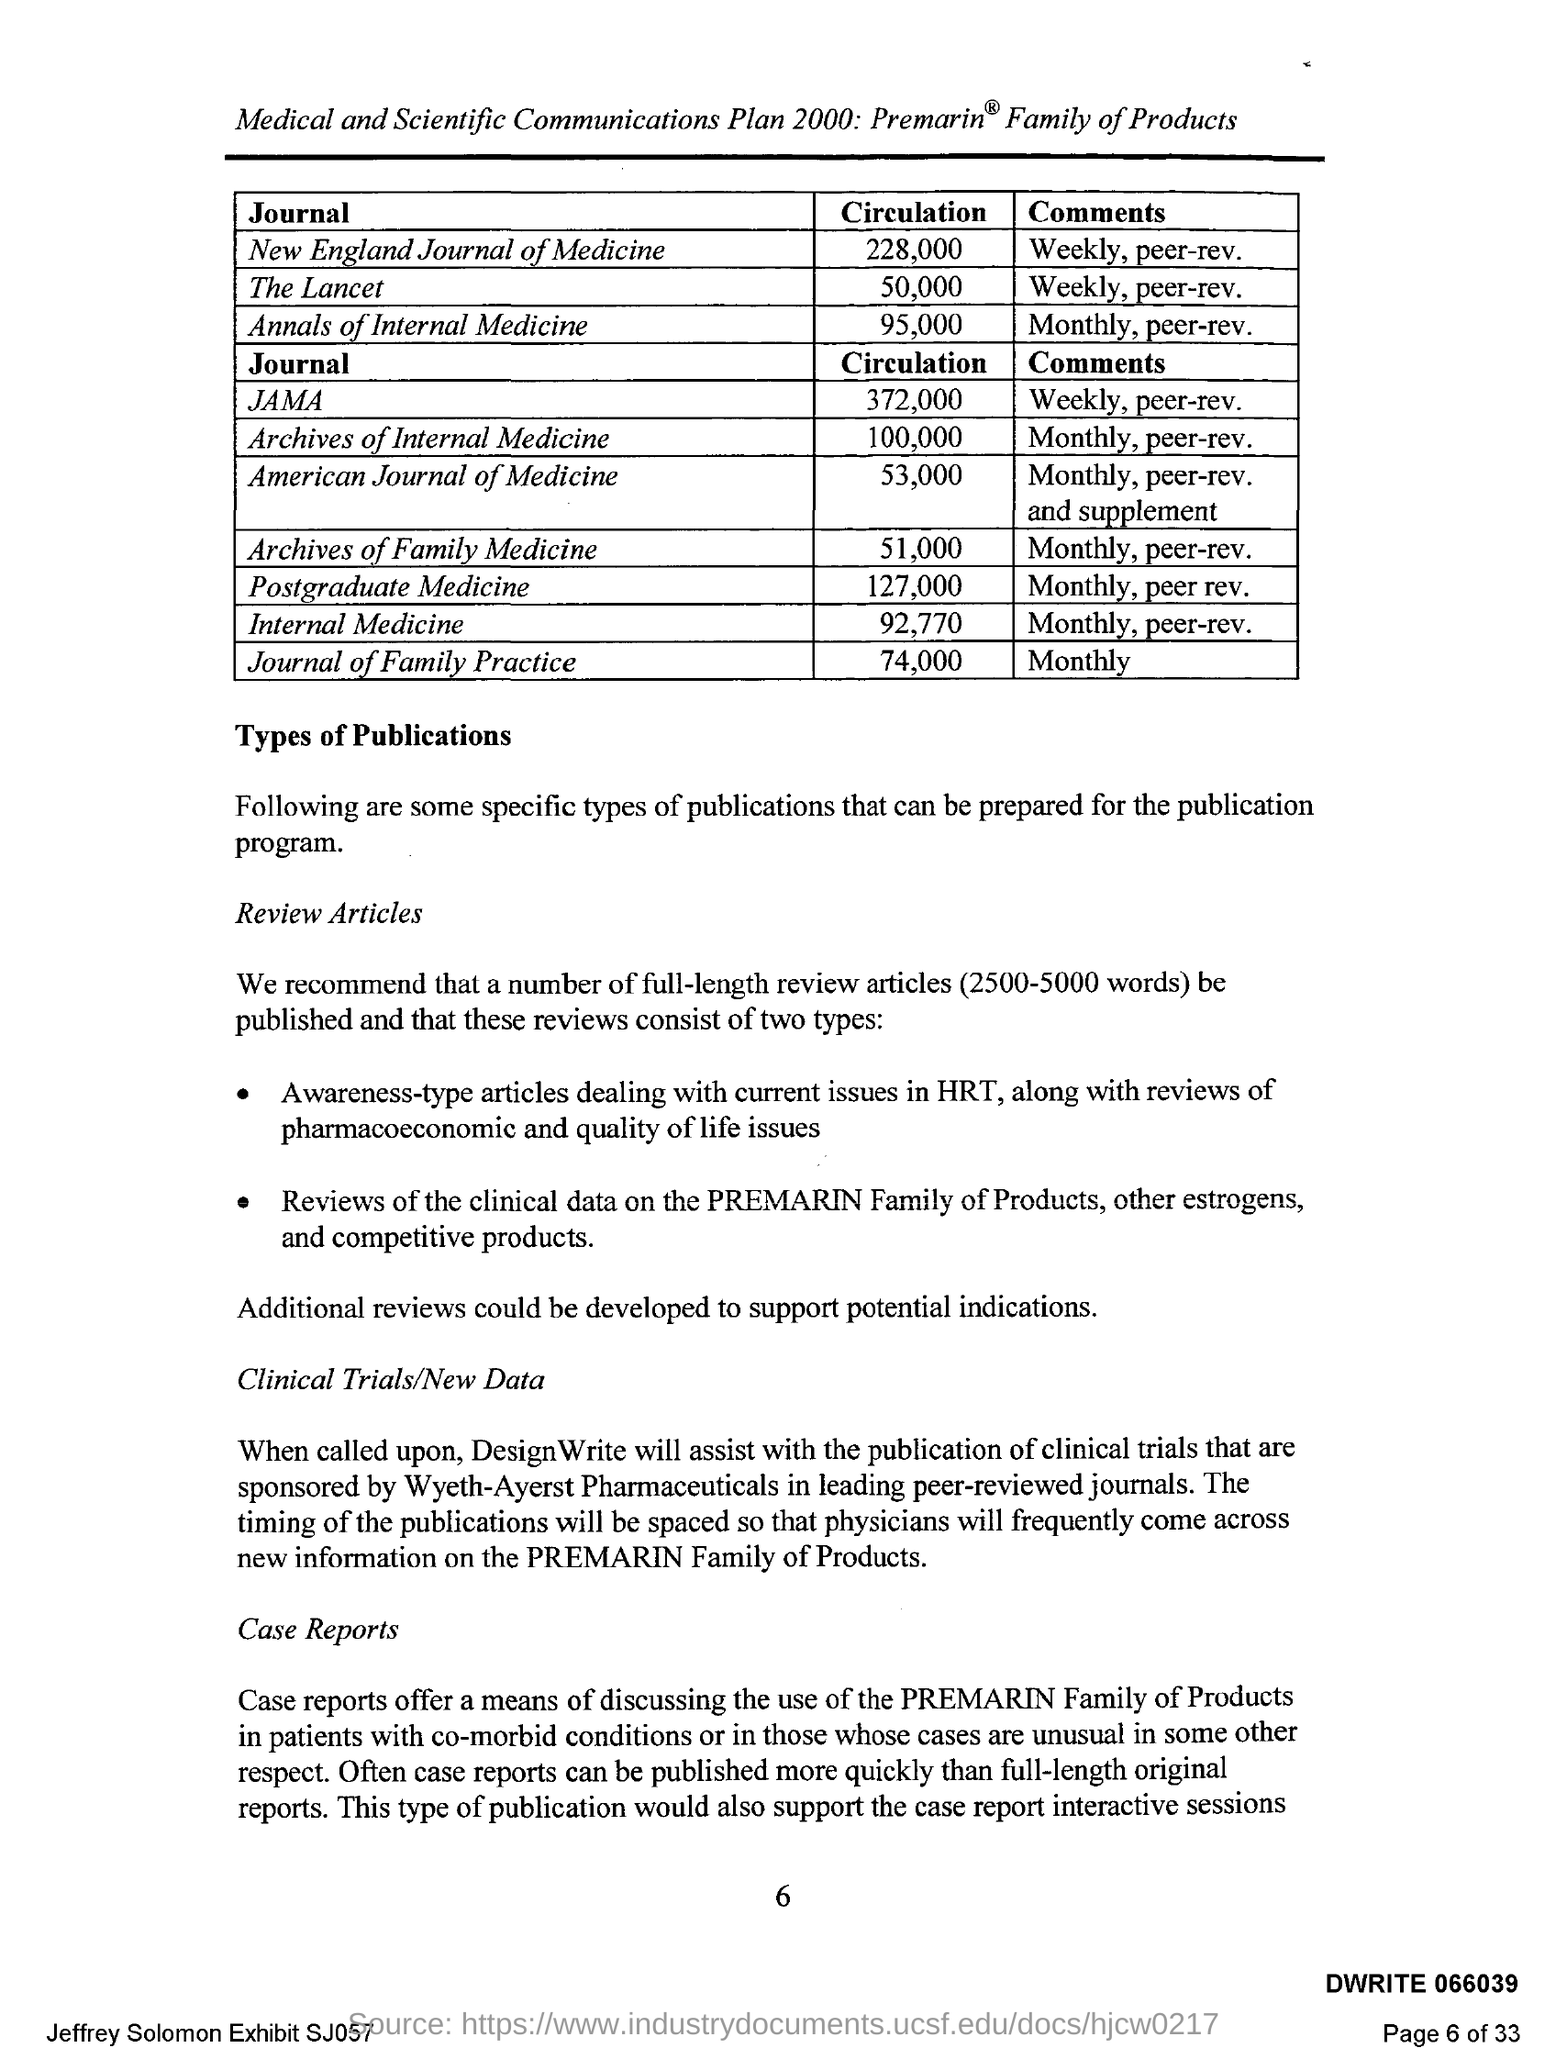What is the number of Page?
Give a very brief answer. 6. What is total number of pages?
Ensure brevity in your answer.  33. What is circulation of JAMA?
Give a very brief answer. 372000. Comments of Journal of Family Practice?
Ensure brevity in your answer.  Monthly. 